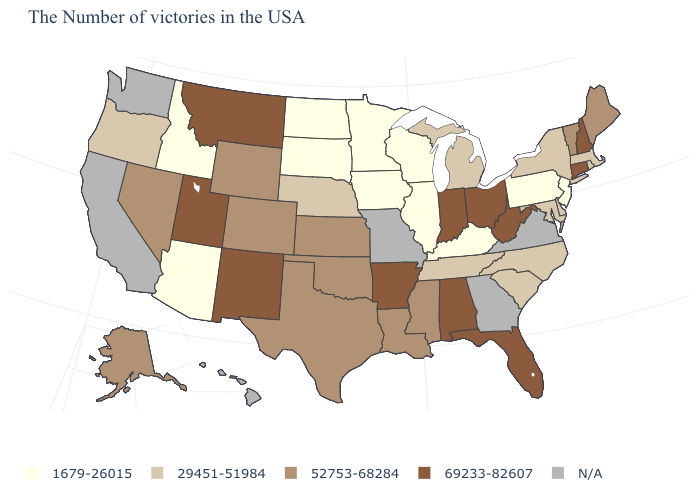Among the states that border Missouri , does Kansas have the highest value?
Give a very brief answer. No. Name the states that have a value in the range 29451-51984?
Quick response, please. Massachusetts, Rhode Island, New York, Delaware, Maryland, North Carolina, South Carolina, Michigan, Tennessee, Nebraska, Oregon. What is the value of Wyoming?
Give a very brief answer. 52753-68284. What is the value of Wyoming?
Concise answer only. 52753-68284. Is the legend a continuous bar?
Short answer required. No. Does the first symbol in the legend represent the smallest category?
Quick response, please. Yes. What is the value of Maryland?
Quick response, please. 29451-51984. Is the legend a continuous bar?
Give a very brief answer. No. Which states have the lowest value in the MidWest?
Be succinct. Wisconsin, Illinois, Minnesota, Iowa, South Dakota, North Dakota. Does Ohio have the lowest value in the MidWest?
Concise answer only. No. Does the first symbol in the legend represent the smallest category?
Answer briefly. Yes. Name the states that have a value in the range 1679-26015?
Write a very short answer. New Jersey, Pennsylvania, Kentucky, Wisconsin, Illinois, Minnesota, Iowa, South Dakota, North Dakota, Arizona, Idaho. Name the states that have a value in the range N/A?
Write a very short answer. Virginia, Georgia, Missouri, California, Washington, Hawaii. Does Florida have the highest value in the USA?
Concise answer only. Yes. 